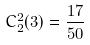<formula> <loc_0><loc_0><loc_500><loc_500>C _ { 2 } ^ { 2 } ( 3 ) = \frac { 1 7 } { 5 0 }</formula> 